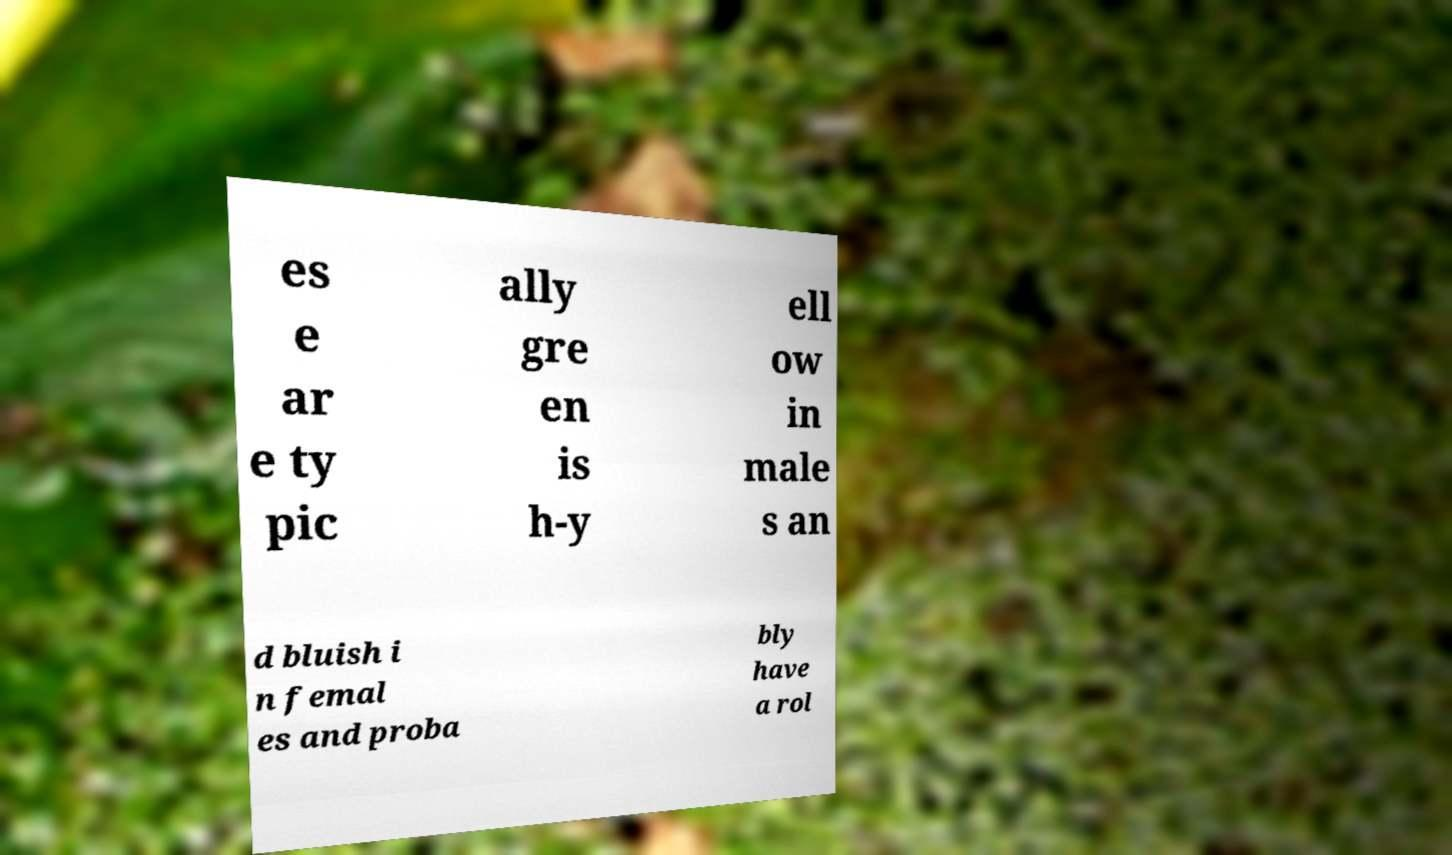I need the written content from this picture converted into text. Can you do that? es e ar e ty pic ally gre en is h-y ell ow in male s an d bluish i n femal es and proba bly have a rol 